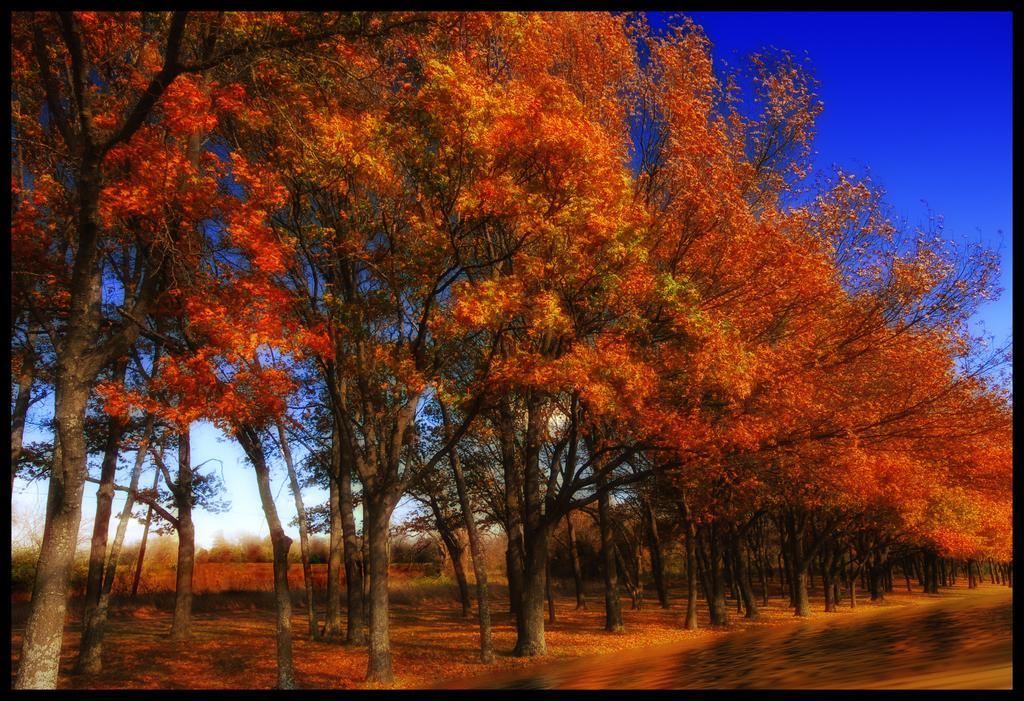Please provide a concise description of this image. Here we can see colorful trees and grass. In the background we can see sky in blue color. 